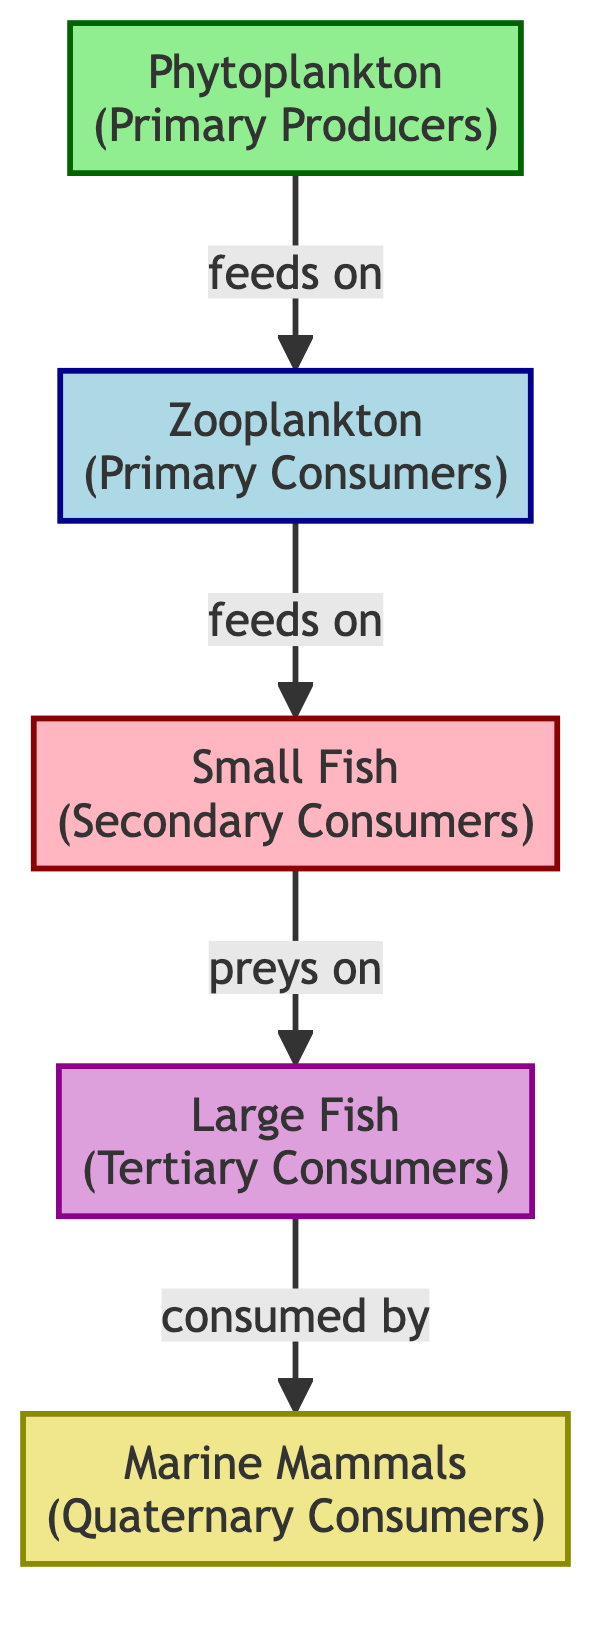What is the primary producer in the diagram? The diagram clearly labels the primary producer as "Phytoplankton". This is the only node categorized under primary producers and is located at the beginning of the food chain.
Answer: Phytoplankton How many levels are there in the food chain? The diagram shows a total of four levels: primary producers, primary consumers, secondary consumers, and tertiary consumers, followed by quaternary consumers. Counting these levels gives a total of four distinct levels.
Answer: 4 What type of consumer is "Zooplankton"? The diagram identifies "Zooplankton" as a primary consumer, indicated by its classification color and label in the diagram.
Answer: Primary Consumer Which organism is at the top of the food chain? The diagram shows "Marine Mammals" at the highest level, labeled as quaternary consumers. This indicates that they occupy the top position in this coastal marine food chain.
Answer: Marine Mammals How many species are classified as secondary consumers? The diagram includes only one species classified as a secondary consumer, which is "Small Fish". This identification is based on the specific label and classification in the food chain.
Answer: 1 What do zooplankton feed on? According to the arrow and label on the diagram, zooplankton feed on phytoplankton. The arrow indicates the feeding relationship between these two groups of organisms.
Answer: Phytoplankton Which organisms are preyed upon by small fish? The diagram illustrates that small fish prey on large fish, as indicated by the directional arrow that connects small fish to large fish. This relationship is clearly denoted in the food chain flow.
Answer: Large Fish What relationship is indicated between small fish and marine mammals? The diagram does not directly indicate a feeding relationship between small fish and marine mammals but rather a flow of energy from small fish to larger fish, which in turn are consumed by marine mammals. Hence, while there is a relationship, it involves multiple levels of the food chain.
Answer: Indirect relationship through large fish What is the primary ecological role of phytoplankton in this food chain? The diagram classifies phytoplankton as "Primary Producers", indicating their role in producing energy through photosynthesis, which serves as the foundational energy source for the entire food chain.
Answer: Primary Producers 